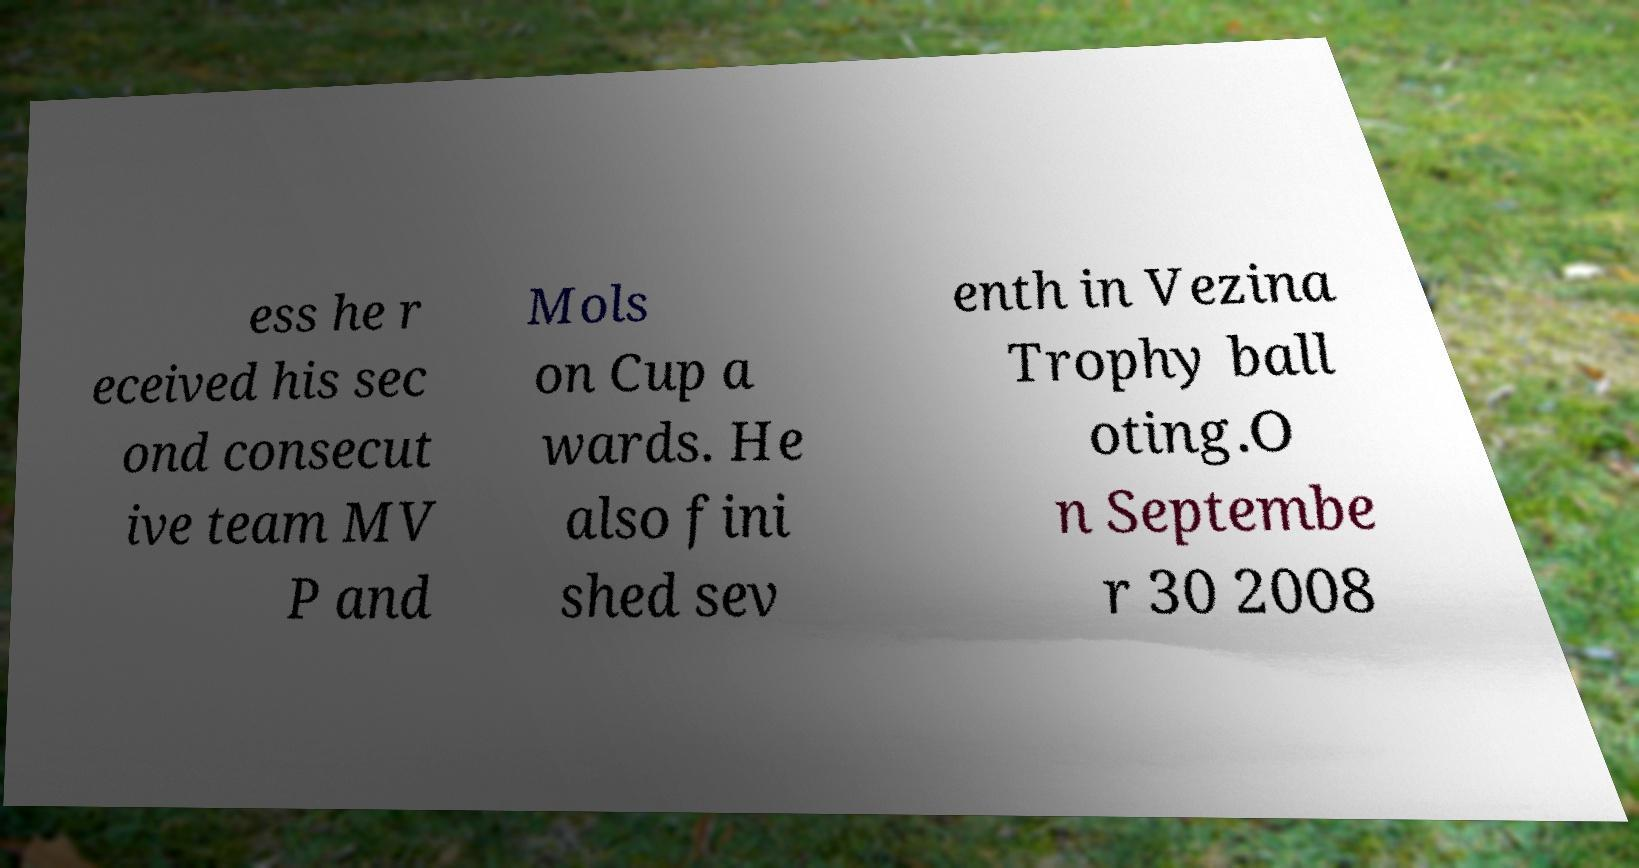Please read and relay the text visible in this image. What does it say? ess he r eceived his sec ond consecut ive team MV P and Mols on Cup a wards. He also fini shed sev enth in Vezina Trophy ball oting.O n Septembe r 30 2008 